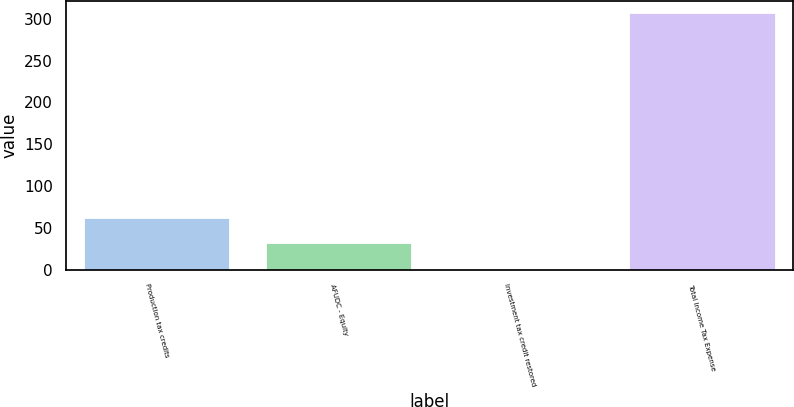<chart> <loc_0><loc_0><loc_500><loc_500><bar_chart><fcel>Production tax credits<fcel>AFUDC - Equity<fcel>Investment tax credit restored<fcel>Total Income Tax Expense<nl><fcel>62.22<fcel>31.71<fcel>1.2<fcel>306.3<nl></chart> 